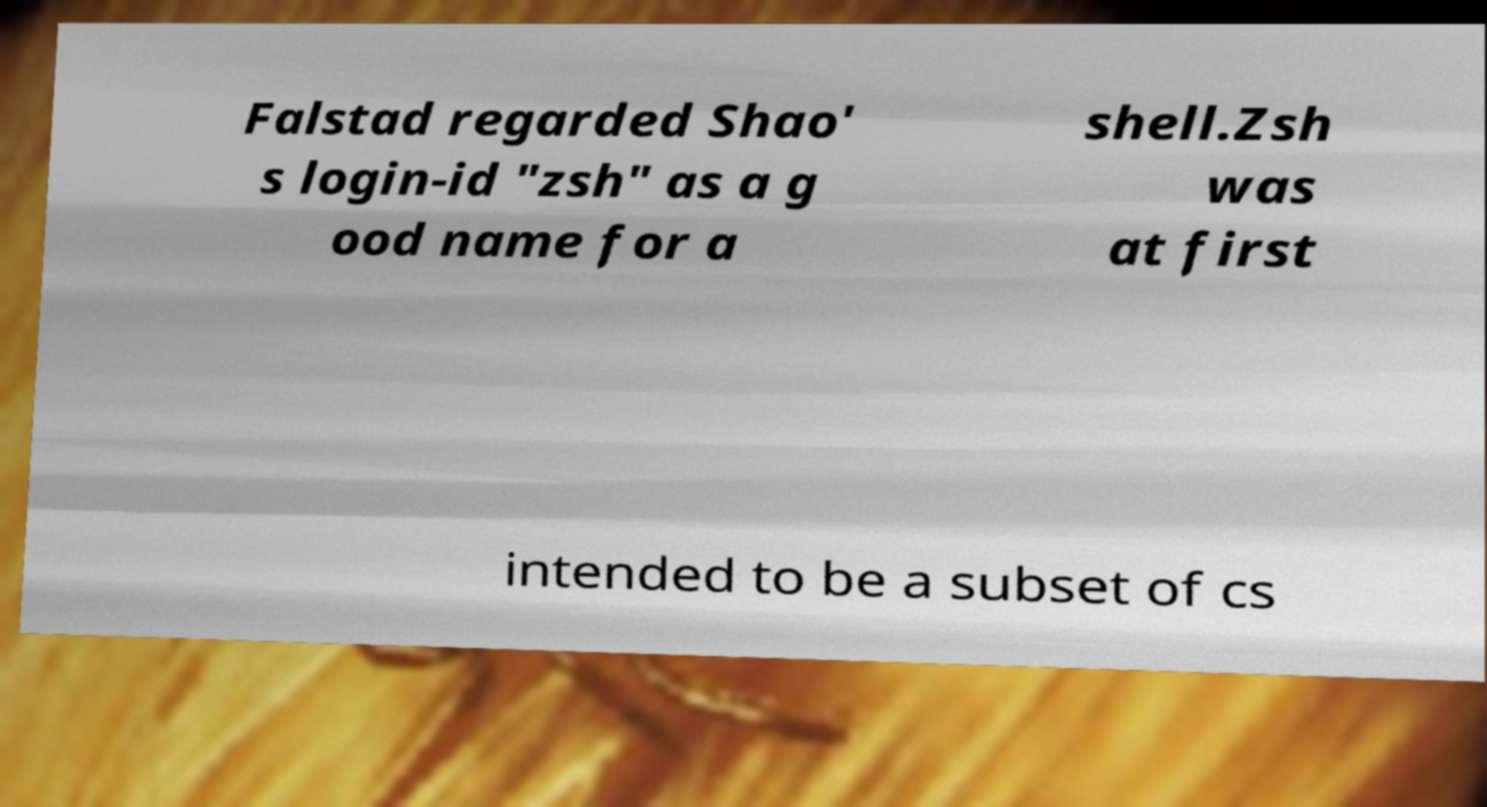Could you assist in decoding the text presented in this image and type it out clearly? Falstad regarded Shao' s login-id "zsh" as a g ood name for a shell.Zsh was at first intended to be a subset of cs 